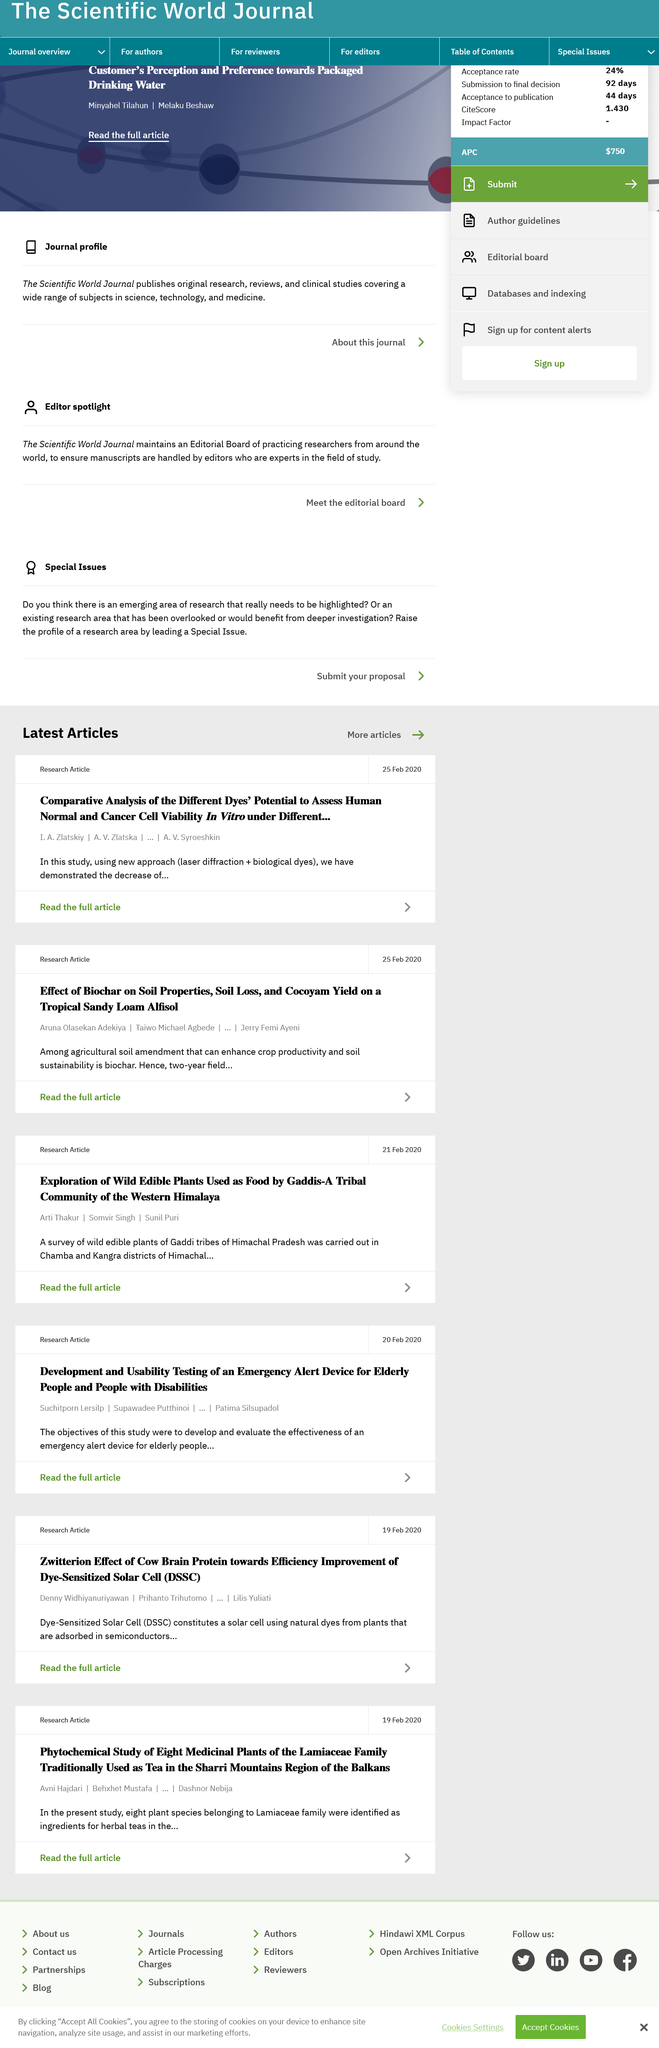Give some essential details in this illustration. One of the contributors to the Biochar research paper is Aruna Olasekan Adekiya, Taiwo Michael Agbede, or Jerry Femi Ayeni. In this research study, a new approach was analyzed that involved the use of laser diffractions and biological dyes. The article examined the soil amendment of biochar, which was utilized for enhancing crop productivity and promoting soil sustainability in agriculture. 